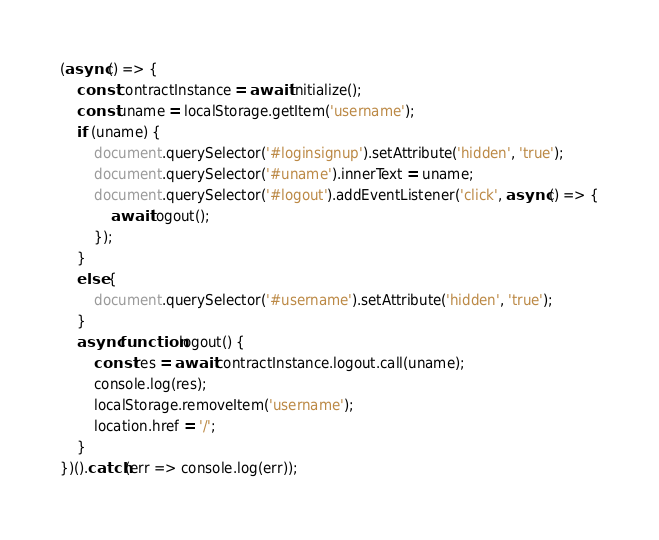Convert code to text. <code><loc_0><loc_0><loc_500><loc_500><_JavaScript_>(async () => {
    const contractInstance = await initialize();
    const uname = localStorage.getItem('username');
    if (uname) {
        document.querySelector('#loginsignup').setAttribute('hidden', 'true');
        document.querySelector('#uname').innerText = uname;
        document.querySelector('#logout').addEventListener('click', async () => {
            await logout();
        });
    }
    else {
        document.querySelector('#username').setAttribute('hidden', 'true');
    }
    async function logout() {
        const res = await contractInstance.logout.call(uname);
        console.log(res);
        localStorage.removeItem('username');
        location.href = '/';
    }
})().catch(err => console.log(err));</code> 